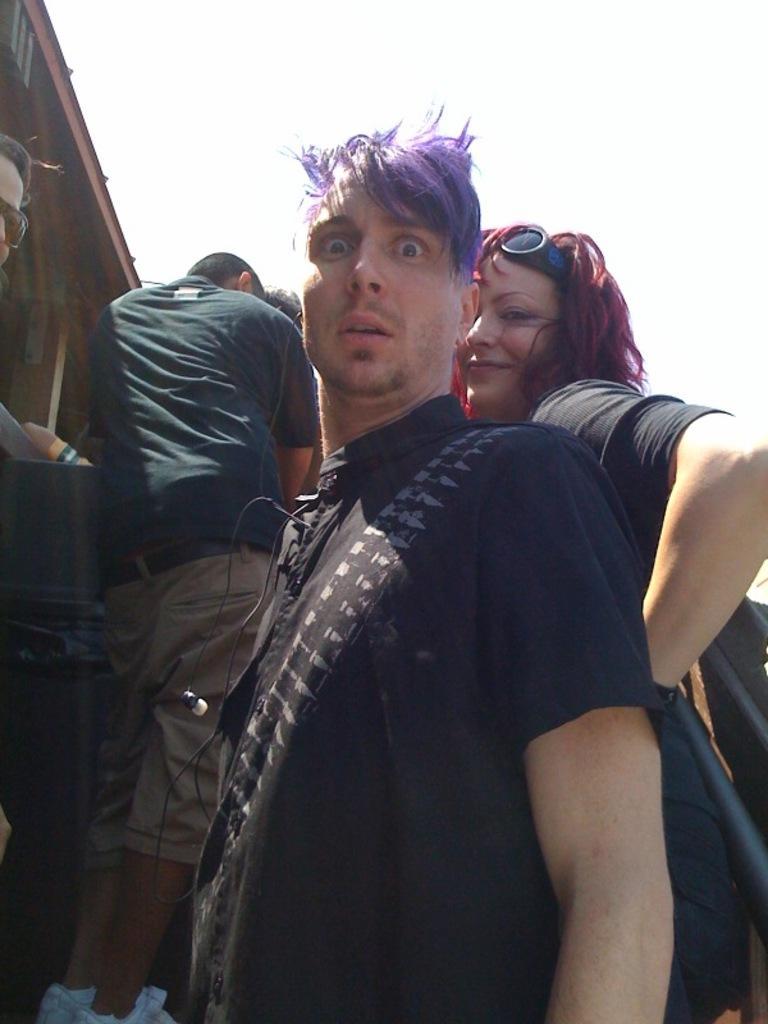Can you describe this image briefly? In this image we can see a person with a headset. Near to him there is a person with a headset. In the back there are few people. On the left side there is a building. Also there is sky. 